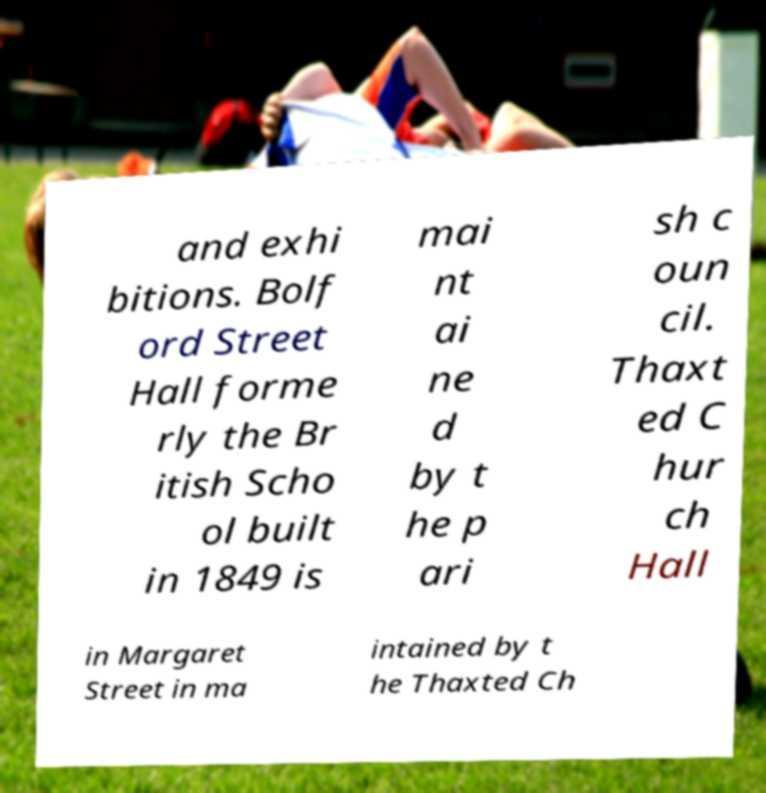Could you assist in decoding the text presented in this image and type it out clearly? and exhi bitions. Bolf ord Street Hall forme rly the Br itish Scho ol built in 1849 is mai nt ai ne d by t he p ari sh c oun cil. Thaxt ed C hur ch Hall in Margaret Street in ma intained by t he Thaxted Ch 